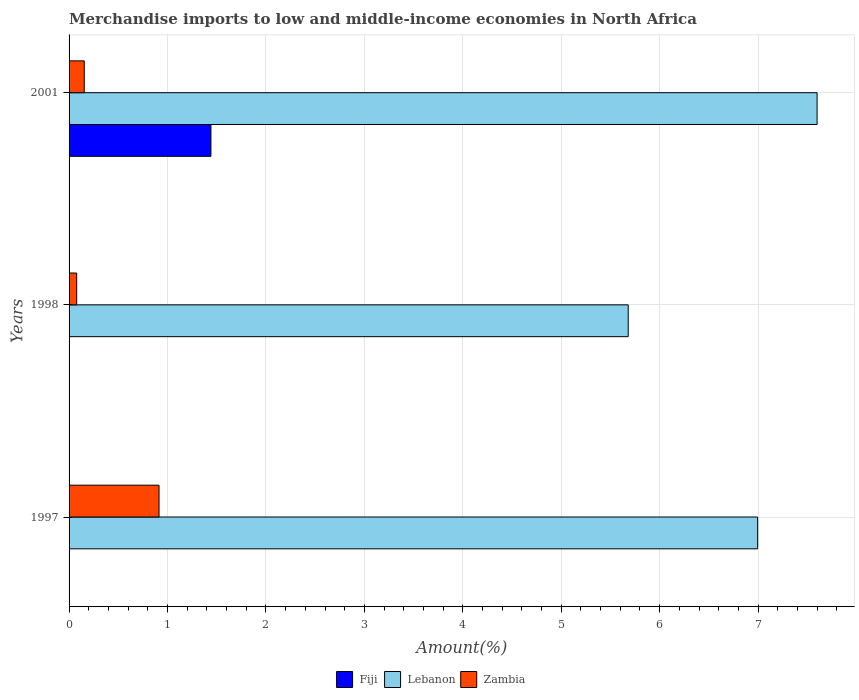How many different coloured bars are there?
Keep it short and to the point. 3. How many groups of bars are there?
Provide a short and direct response. 3. Are the number of bars per tick equal to the number of legend labels?
Keep it short and to the point. Yes. How many bars are there on the 1st tick from the top?
Offer a terse response. 3. How many bars are there on the 2nd tick from the bottom?
Ensure brevity in your answer.  3. What is the percentage of amount earned from merchandise imports in Zambia in 1997?
Offer a terse response. 0.91. Across all years, what is the maximum percentage of amount earned from merchandise imports in Zambia?
Ensure brevity in your answer.  0.91. Across all years, what is the minimum percentage of amount earned from merchandise imports in Lebanon?
Your response must be concise. 5.68. In which year was the percentage of amount earned from merchandise imports in Lebanon maximum?
Keep it short and to the point. 2001. In which year was the percentage of amount earned from merchandise imports in Fiji minimum?
Your answer should be very brief. 1997. What is the total percentage of amount earned from merchandise imports in Zambia in the graph?
Offer a terse response. 1.15. What is the difference between the percentage of amount earned from merchandise imports in Lebanon in 1998 and that in 2001?
Provide a succinct answer. -1.92. What is the difference between the percentage of amount earned from merchandise imports in Zambia in 1997 and the percentage of amount earned from merchandise imports in Fiji in 1998?
Ensure brevity in your answer.  0.91. What is the average percentage of amount earned from merchandise imports in Zambia per year?
Your answer should be very brief. 0.38. In the year 1997, what is the difference between the percentage of amount earned from merchandise imports in Lebanon and percentage of amount earned from merchandise imports in Fiji?
Your response must be concise. 6.99. In how many years, is the percentage of amount earned from merchandise imports in Lebanon greater than 6.2 %?
Give a very brief answer. 2. What is the ratio of the percentage of amount earned from merchandise imports in Fiji in 1997 to that in 2001?
Provide a succinct answer. 0. Is the percentage of amount earned from merchandise imports in Lebanon in 1997 less than that in 1998?
Provide a succinct answer. No. What is the difference between the highest and the second highest percentage of amount earned from merchandise imports in Lebanon?
Your answer should be compact. 0.6. What is the difference between the highest and the lowest percentage of amount earned from merchandise imports in Zambia?
Provide a succinct answer. 0.84. What does the 2nd bar from the top in 1998 represents?
Your answer should be very brief. Lebanon. What does the 2nd bar from the bottom in 1998 represents?
Offer a very short reply. Lebanon. Are all the bars in the graph horizontal?
Ensure brevity in your answer.  Yes. Are the values on the major ticks of X-axis written in scientific E-notation?
Your answer should be very brief. No. Does the graph contain grids?
Offer a terse response. Yes. Where does the legend appear in the graph?
Your answer should be compact. Bottom center. How are the legend labels stacked?
Keep it short and to the point. Horizontal. What is the title of the graph?
Give a very brief answer. Merchandise imports to low and middle-income economies in North Africa. Does "Nigeria" appear as one of the legend labels in the graph?
Offer a terse response. No. What is the label or title of the X-axis?
Provide a short and direct response. Amount(%). What is the label or title of the Y-axis?
Keep it short and to the point. Years. What is the Amount(%) in Fiji in 1997?
Make the answer very short. 0. What is the Amount(%) of Lebanon in 1997?
Provide a short and direct response. 7. What is the Amount(%) of Zambia in 1997?
Offer a very short reply. 0.91. What is the Amount(%) in Fiji in 1998?
Offer a terse response. 0. What is the Amount(%) of Lebanon in 1998?
Offer a terse response. 5.68. What is the Amount(%) in Zambia in 1998?
Offer a very short reply. 0.08. What is the Amount(%) in Fiji in 2001?
Provide a short and direct response. 1.44. What is the Amount(%) of Lebanon in 2001?
Your response must be concise. 7.6. What is the Amount(%) in Zambia in 2001?
Provide a short and direct response. 0.15. Across all years, what is the maximum Amount(%) of Fiji?
Offer a very short reply. 1.44. Across all years, what is the maximum Amount(%) in Lebanon?
Offer a very short reply. 7.6. Across all years, what is the maximum Amount(%) in Zambia?
Offer a terse response. 0.91. Across all years, what is the minimum Amount(%) in Fiji?
Provide a succinct answer. 0. Across all years, what is the minimum Amount(%) in Lebanon?
Keep it short and to the point. 5.68. Across all years, what is the minimum Amount(%) in Zambia?
Your answer should be very brief. 0.08. What is the total Amount(%) in Fiji in the graph?
Give a very brief answer. 1.45. What is the total Amount(%) in Lebanon in the graph?
Your answer should be very brief. 20.27. What is the total Amount(%) of Zambia in the graph?
Provide a short and direct response. 1.15. What is the difference between the Amount(%) of Fiji in 1997 and that in 1998?
Offer a very short reply. -0. What is the difference between the Amount(%) in Lebanon in 1997 and that in 1998?
Your answer should be compact. 1.31. What is the difference between the Amount(%) in Zambia in 1997 and that in 1998?
Your answer should be compact. 0.84. What is the difference between the Amount(%) of Fiji in 1997 and that in 2001?
Make the answer very short. -1.44. What is the difference between the Amount(%) in Lebanon in 1997 and that in 2001?
Provide a succinct answer. -0.6. What is the difference between the Amount(%) of Zambia in 1997 and that in 2001?
Give a very brief answer. 0.76. What is the difference between the Amount(%) in Fiji in 1998 and that in 2001?
Ensure brevity in your answer.  -1.44. What is the difference between the Amount(%) of Lebanon in 1998 and that in 2001?
Give a very brief answer. -1.92. What is the difference between the Amount(%) of Zambia in 1998 and that in 2001?
Your response must be concise. -0.08. What is the difference between the Amount(%) of Fiji in 1997 and the Amount(%) of Lebanon in 1998?
Your response must be concise. -5.68. What is the difference between the Amount(%) of Fiji in 1997 and the Amount(%) of Zambia in 1998?
Your answer should be very brief. -0.08. What is the difference between the Amount(%) of Lebanon in 1997 and the Amount(%) of Zambia in 1998?
Ensure brevity in your answer.  6.92. What is the difference between the Amount(%) of Fiji in 1997 and the Amount(%) of Lebanon in 2001?
Your answer should be compact. -7.6. What is the difference between the Amount(%) in Fiji in 1997 and the Amount(%) in Zambia in 2001?
Your answer should be compact. -0.15. What is the difference between the Amount(%) of Lebanon in 1997 and the Amount(%) of Zambia in 2001?
Ensure brevity in your answer.  6.84. What is the difference between the Amount(%) of Fiji in 1998 and the Amount(%) of Lebanon in 2001?
Provide a succinct answer. -7.6. What is the difference between the Amount(%) of Fiji in 1998 and the Amount(%) of Zambia in 2001?
Provide a short and direct response. -0.15. What is the difference between the Amount(%) in Lebanon in 1998 and the Amount(%) in Zambia in 2001?
Keep it short and to the point. 5.53. What is the average Amount(%) in Fiji per year?
Make the answer very short. 0.48. What is the average Amount(%) in Lebanon per year?
Offer a very short reply. 6.76. What is the average Amount(%) in Zambia per year?
Your answer should be compact. 0.38. In the year 1997, what is the difference between the Amount(%) of Fiji and Amount(%) of Lebanon?
Your answer should be compact. -6.99. In the year 1997, what is the difference between the Amount(%) of Fiji and Amount(%) of Zambia?
Provide a short and direct response. -0.91. In the year 1997, what is the difference between the Amount(%) in Lebanon and Amount(%) in Zambia?
Provide a short and direct response. 6.08. In the year 1998, what is the difference between the Amount(%) in Fiji and Amount(%) in Lebanon?
Provide a short and direct response. -5.68. In the year 1998, what is the difference between the Amount(%) of Fiji and Amount(%) of Zambia?
Keep it short and to the point. -0.07. In the year 1998, what is the difference between the Amount(%) of Lebanon and Amount(%) of Zambia?
Your answer should be compact. 5.6. In the year 2001, what is the difference between the Amount(%) in Fiji and Amount(%) in Lebanon?
Give a very brief answer. -6.16. In the year 2001, what is the difference between the Amount(%) of Fiji and Amount(%) of Zambia?
Keep it short and to the point. 1.29. In the year 2001, what is the difference between the Amount(%) of Lebanon and Amount(%) of Zambia?
Ensure brevity in your answer.  7.45. What is the ratio of the Amount(%) in Fiji in 1997 to that in 1998?
Give a very brief answer. 0.48. What is the ratio of the Amount(%) in Lebanon in 1997 to that in 1998?
Keep it short and to the point. 1.23. What is the ratio of the Amount(%) of Zambia in 1997 to that in 1998?
Offer a terse response. 11.8. What is the ratio of the Amount(%) in Fiji in 1997 to that in 2001?
Ensure brevity in your answer.  0. What is the ratio of the Amount(%) of Lebanon in 1997 to that in 2001?
Provide a short and direct response. 0.92. What is the ratio of the Amount(%) of Zambia in 1997 to that in 2001?
Your answer should be very brief. 5.93. What is the ratio of the Amount(%) in Fiji in 1998 to that in 2001?
Ensure brevity in your answer.  0. What is the ratio of the Amount(%) in Lebanon in 1998 to that in 2001?
Your response must be concise. 0.75. What is the ratio of the Amount(%) of Zambia in 1998 to that in 2001?
Keep it short and to the point. 0.5. What is the difference between the highest and the second highest Amount(%) of Fiji?
Your answer should be compact. 1.44. What is the difference between the highest and the second highest Amount(%) in Lebanon?
Offer a very short reply. 0.6. What is the difference between the highest and the second highest Amount(%) in Zambia?
Give a very brief answer. 0.76. What is the difference between the highest and the lowest Amount(%) in Fiji?
Keep it short and to the point. 1.44. What is the difference between the highest and the lowest Amount(%) in Lebanon?
Offer a terse response. 1.92. What is the difference between the highest and the lowest Amount(%) in Zambia?
Make the answer very short. 0.84. 